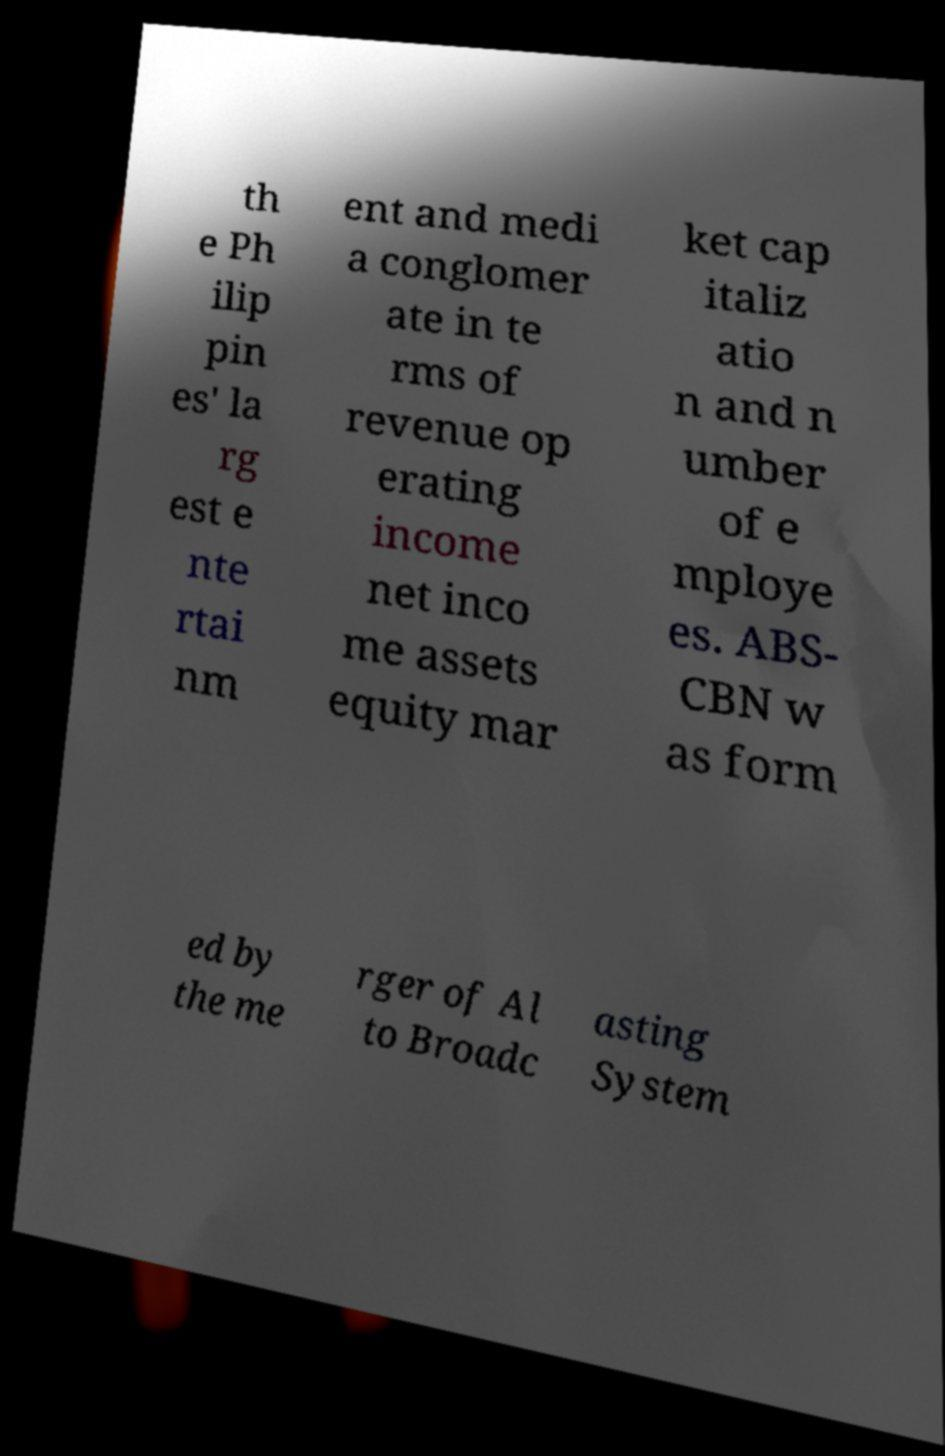For documentation purposes, I need the text within this image transcribed. Could you provide that? th e Ph ilip pin es' la rg est e nte rtai nm ent and medi a conglomer ate in te rms of revenue op erating income net inco me assets equity mar ket cap italiz atio n and n umber of e mploye es. ABS- CBN w as form ed by the me rger of Al to Broadc asting System 